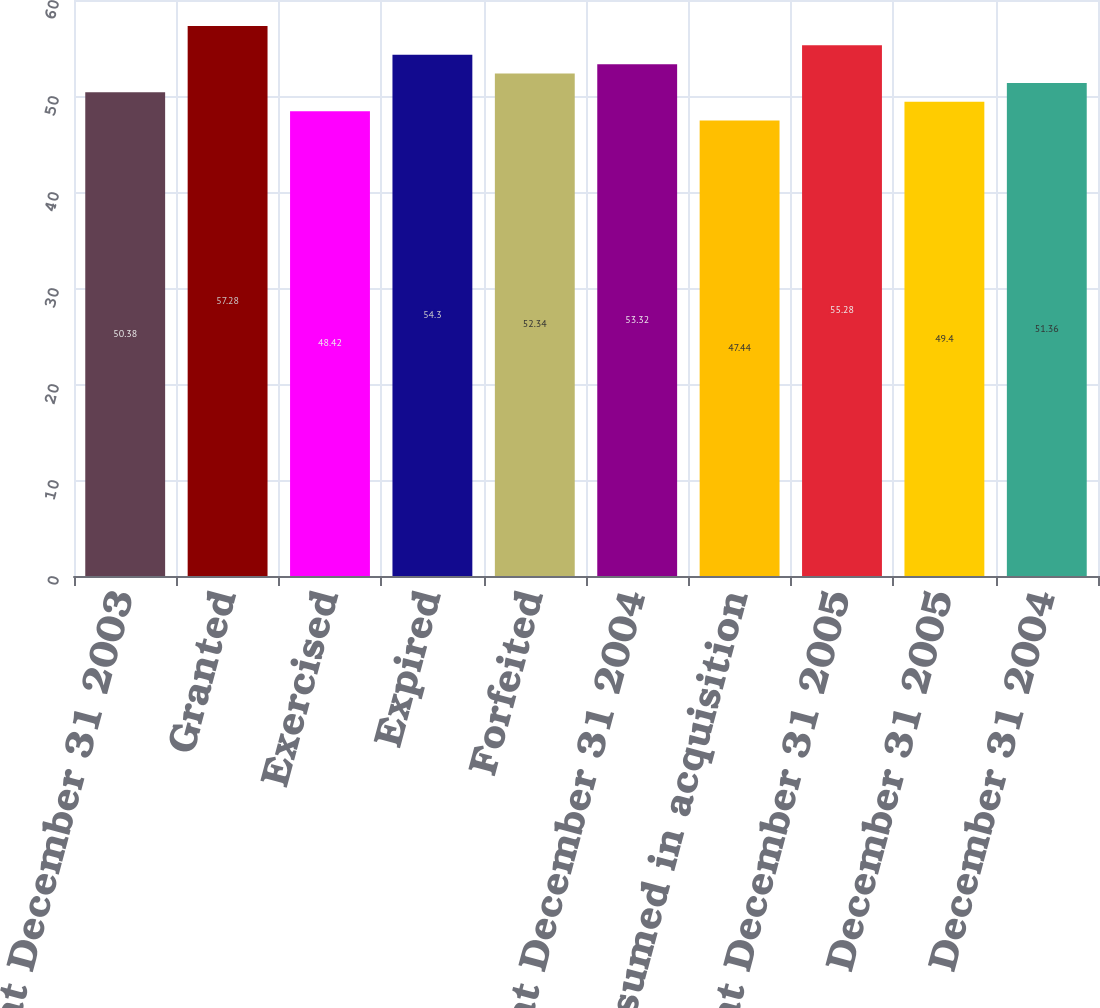Convert chart. <chart><loc_0><loc_0><loc_500><loc_500><bar_chart><fcel>Balance at December 31 2003<fcel>Granted<fcel>Exercised<fcel>Expired<fcel>Forfeited<fcel>Balance at December 31 2004<fcel>Assumed in acquisition<fcel>Balance at December 31 2005<fcel>December 31 2005<fcel>December 31 2004<nl><fcel>50.38<fcel>57.28<fcel>48.42<fcel>54.3<fcel>52.34<fcel>53.32<fcel>47.44<fcel>55.28<fcel>49.4<fcel>51.36<nl></chart> 